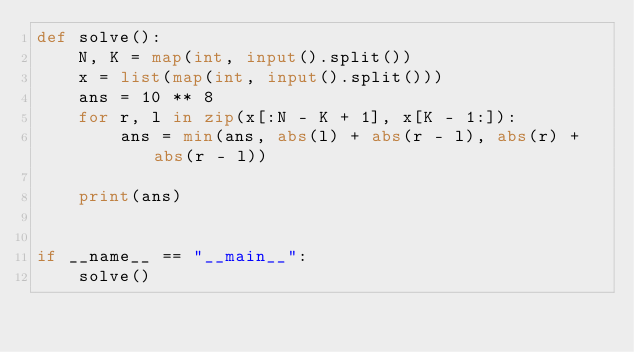Convert code to text. <code><loc_0><loc_0><loc_500><loc_500><_Python_>def solve():
    N, K = map(int, input().split())
    x = list(map(int, input().split()))
    ans = 10 ** 8
    for r, l in zip(x[:N - K + 1], x[K - 1:]):
        ans = min(ans, abs(l) + abs(r - l), abs(r) + abs(r - l))

    print(ans)


if __name__ == "__main__":
    solve()
</code> 